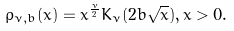<formula> <loc_0><loc_0><loc_500><loc_500>\rho _ { \nu , b } ( x ) = x ^ { \frac { \nu } { 2 } } K _ { \nu } ( 2 b \sqrt { x } ) , x > 0 .</formula> 